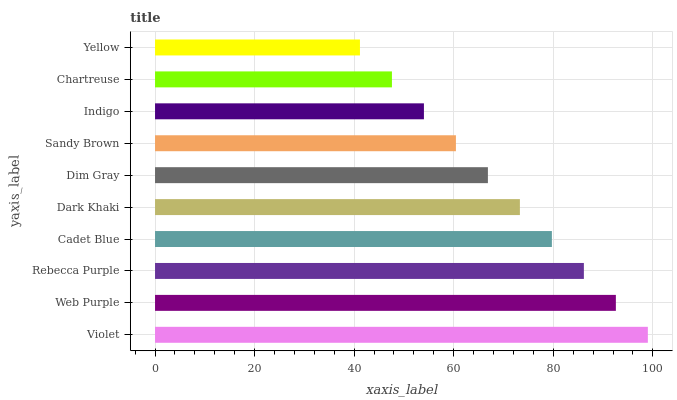Is Yellow the minimum?
Answer yes or no. Yes. Is Violet the maximum?
Answer yes or no. Yes. Is Web Purple the minimum?
Answer yes or no. No. Is Web Purple the maximum?
Answer yes or no. No. Is Violet greater than Web Purple?
Answer yes or no. Yes. Is Web Purple less than Violet?
Answer yes or no. Yes. Is Web Purple greater than Violet?
Answer yes or no. No. Is Violet less than Web Purple?
Answer yes or no. No. Is Dark Khaki the high median?
Answer yes or no. Yes. Is Dim Gray the low median?
Answer yes or no. Yes. Is Rebecca Purple the high median?
Answer yes or no. No. Is Yellow the low median?
Answer yes or no. No. 